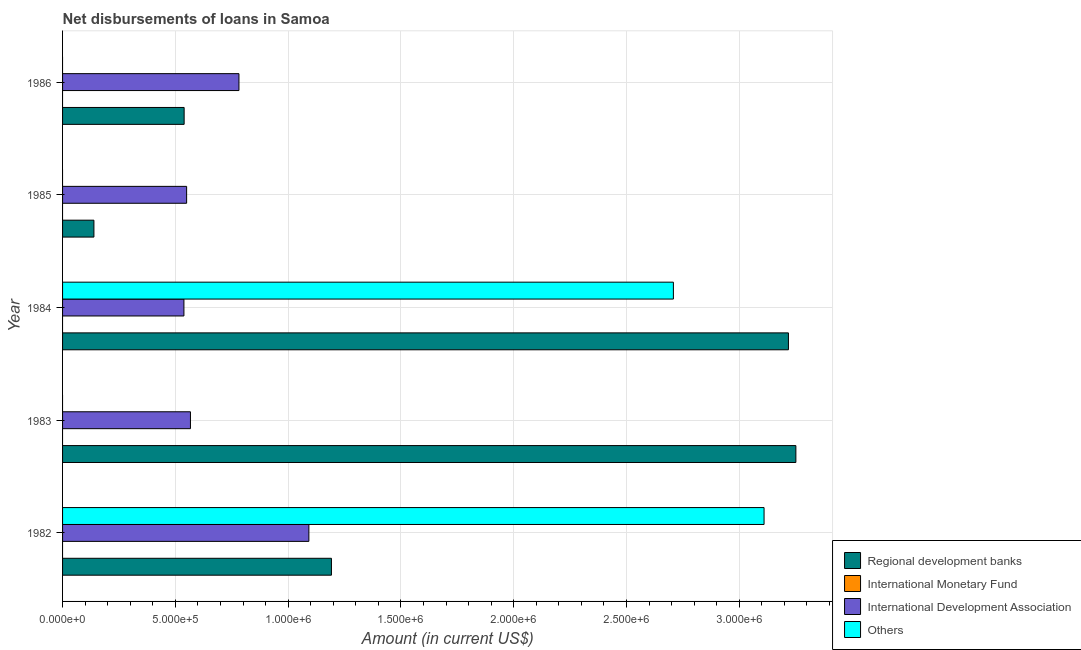Are the number of bars per tick equal to the number of legend labels?
Offer a terse response. No. Are the number of bars on each tick of the Y-axis equal?
Offer a terse response. No. What is the label of the 4th group of bars from the top?
Provide a succinct answer. 1983. In how many cases, is the number of bars for a given year not equal to the number of legend labels?
Provide a short and direct response. 5. Across all years, what is the maximum amount of loan disimbursed by other organisations?
Give a very brief answer. 3.11e+06. Across all years, what is the minimum amount of loan disimbursed by regional development banks?
Give a very brief answer. 1.39e+05. What is the total amount of loan disimbursed by regional development banks in the graph?
Offer a very short reply. 8.34e+06. What is the difference between the amount of loan disimbursed by regional development banks in 1982 and that in 1984?
Give a very brief answer. -2.03e+06. What is the difference between the amount of loan disimbursed by other organisations in 1986 and the amount of loan disimbursed by regional development banks in 1982?
Give a very brief answer. -1.19e+06. What is the average amount of loan disimbursed by other organisations per year?
Ensure brevity in your answer.  1.16e+06. In the year 1982, what is the difference between the amount of loan disimbursed by international development association and amount of loan disimbursed by other organisations?
Give a very brief answer. -2.02e+06. In how many years, is the amount of loan disimbursed by regional development banks greater than 1300000 US$?
Offer a terse response. 2. What is the ratio of the amount of loan disimbursed by international development association in 1984 to that in 1986?
Offer a terse response. 0.69. What is the difference between the highest and the second highest amount of loan disimbursed by regional development banks?
Offer a terse response. 3.30e+04. What is the difference between the highest and the lowest amount of loan disimbursed by international development association?
Your response must be concise. 5.54e+05. In how many years, is the amount of loan disimbursed by international development association greater than the average amount of loan disimbursed by international development association taken over all years?
Your answer should be compact. 2. Is it the case that in every year, the sum of the amount of loan disimbursed by other organisations and amount of loan disimbursed by international monetary fund is greater than the sum of amount of loan disimbursed by regional development banks and amount of loan disimbursed by international development association?
Provide a succinct answer. No. Are all the bars in the graph horizontal?
Your answer should be very brief. Yes. How many years are there in the graph?
Ensure brevity in your answer.  5. What is the difference between two consecutive major ticks on the X-axis?
Your answer should be compact. 5.00e+05. Are the values on the major ticks of X-axis written in scientific E-notation?
Keep it short and to the point. Yes. Does the graph contain grids?
Ensure brevity in your answer.  Yes. What is the title of the graph?
Give a very brief answer. Net disbursements of loans in Samoa. What is the label or title of the Y-axis?
Offer a very short reply. Year. What is the Amount (in current US$) of Regional development banks in 1982?
Your response must be concise. 1.19e+06. What is the Amount (in current US$) in International Monetary Fund in 1982?
Provide a succinct answer. 0. What is the Amount (in current US$) of International Development Association in 1982?
Provide a succinct answer. 1.09e+06. What is the Amount (in current US$) of Others in 1982?
Provide a short and direct response. 3.11e+06. What is the Amount (in current US$) in Regional development banks in 1983?
Your answer should be very brief. 3.25e+06. What is the Amount (in current US$) of International Monetary Fund in 1983?
Offer a terse response. 0. What is the Amount (in current US$) of International Development Association in 1983?
Your response must be concise. 5.67e+05. What is the Amount (in current US$) in Regional development banks in 1984?
Offer a terse response. 3.22e+06. What is the Amount (in current US$) in International Monetary Fund in 1984?
Make the answer very short. 0. What is the Amount (in current US$) in International Development Association in 1984?
Ensure brevity in your answer.  5.38e+05. What is the Amount (in current US$) of Others in 1984?
Your answer should be compact. 2.71e+06. What is the Amount (in current US$) of Regional development banks in 1985?
Your answer should be very brief. 1.39e+05. What is the Amount (in current US$) in International Monetary Fund in 1985?
Provide a succinct answer. 0. What is the Amount (in current US$) of International Development Association in 1985?
Your answer should be compact. 5.50e+05. What is the Amount (in current US$) of Others in 1985?
Make the answer very short. 0. What is the Amount (in current US$) of Regional development banks in 1986?
Keep it short and to the point. 5.39e+05. What is the Amount (in current US$) in International Development Association in 1986?
Your answer should be very brief. 7.82e+05. What is the Amount (in current US$) of Others in 1986?
Offer a terse response. 0. Across all years, what is the maximum Amount (in current US$) in Regional development banks?
Provide a succinct answer. 3.25e+06. Across all years, what is the maximum Amount (in current US$) in International Development Association?
Make the answer very short. 1.09e+06. Across all years, what is the maximum Amount (in current US$) in Others?
Your answer should be very brief. 3.11e+06. Across all years, what is the minimum Amount (in current US$) of Regional development banks?
Your answer should be very brief. 1.39e+05. Across all years, what is the minimum Amount (in current US$) in International Development Association?
Your answer should be compact. 5.38e+05. What is the total Amount (in current US$) in Regional development banks in the graph?
Offer a terse response. 8.34e+06. What is the total Amount (in current US$) in International Development Association in the graph?
Provide a succinct answer. 3.53e+06. What is the total Amount (in current US$) of Others in the graph?
Make the answer very short. 5.82e+06. What is the difference between the Amount (in current US$) in Regional development banks in 1982 and that in 1983?
Keep it short and to the point. -2.06e+06. What is the difference between the Amount (in current US$) in International Development Association in 1982 and that in 1983?
Provide a succinct answer. 5.25e+05. What is the difference between the Amount (in current US$) of Regional development banks in 1982 and that in 1984?
Your answer should be compact. -2.03e+06. What is the difference between the Amount (in current US$) in International Development Association in 1982 and that in 1984?
Offer a very short reply. 5.54e+05. What is the difference between the Amount (in current US$) of Others in 1982 and that in 1984?
Keep it short and to the point. 4.02e+05. What is the difference between the Amount (in current US$) of Regional development banks in 1982 and that in 1985?
Offer a terse response. 1.05e+06. What is the difference between the Amount (in current US$) in International Development Association in 1982 and that in 1985?
Provide a succinct answer. 5.42e+05. What is the difference between the Amount (in current US$) in Regional development banks in 1982 and that in 1986?
Make the answer very short. 6.53e+05. What is the difference between the Amount (in current US$) in Regional development banks in 1983 and that in 1984?
Provide a succinct answer. 3.30e+04. What is the difference between the Amount (in current US$) of International Development Association in 1983 and that in 1984?
Provide a short and direct response. 2.90e+04. What is the difference between the Amount (in current US$) in Regional development banks in 1983 and that in 1985?
Your response must be concise. 3.11e+06. What is the difference between the Amount (in current US$) in International Development Association in 1983 and that in 1985?
Make the answer very short. 1.70e+04. What is the difference between the Amount (in current US$) in Regional development banks in 1983 and that in 1986?
Make the answer very short. 2.71e+06. What is the difference between the Amount (in current US$) of International Development Association in 1983 and that in 1986?
Your answer should be compact. -2.15e+05. What is the difference between the Amount (in current US$) of Regional development banks in 1984 and that in 1985?
Your answer should be compact. 3.08e+06. What is the difference between the Amount (in current US$) in International Development Association in 1984 and that in 1985?
Provide a short and direct response. -1.20e+04. What is the difference between the Amount (in current US$) in Regional development banks in 1984 and that in 1986?
Keep it short and to the point. 2.68e+06. What is the difference between the Amount (in current US$) in International Development Association in 1984 and that in 1986?
Keep it short and to the point. -2.44e+05. What is the difference between the Amount (in current US$) of Regional development banks in 1985 and that in 1986?
Keep it short and to the point. -4.00e+05. What is the difference between the Amount (in current US$) in International Development Association in 1985 and that in 1986?
Offer a very short reply. -2.32e+05. What is the difference between the Amount (in current US$) in Regional development banks in 1982 and the Amount (in current US$) in International Development Association in 1983?
Provide a short and direct response. 6.25e+05. What is the difference between the Amount (in current US$) of Regional development banks in 1982 and the Amount (in current US$) of International Development Association in 1984?
Provide a succinct answer. 6.54e+05. What is the difference between the Amount (in current US$) in Regional development banks in 1982 and the Amount (in current US$) in Others in 1984?
Your answer should be compact. -1.52e+06. What is the difference between the Amount (in current US$) of International Development Association in 1982 and the Amount (in current US$) of Others in 1984?
Provide a short and direct response. -1.62e+06. What is the difference between the Amount (in current US$) of Regional development banks in 1982 and the Amount (in current US$) of International Development Association in 1985?
Make the answer very short. 6.42e+05. What is the difference between the Amount (in current US$) in Regional development banks in 1982 and the Amount (in current US$) in International Development Association in 1986?
Offer a terse response. 4.10e+05. What is the difference between the Amount (in current US$) in Regional development banks in 1983 and the Amount (in current US$) in International Development Association in 1984?
Offer a very short reply. 2.71e+06. What is the difference between the Amount (in current US$) of Regional development banks in 1983 and the Amount (in current US$) of Others in 1984?
Ensure brevity in your answer.  5.43e+05. What is the difference between the Amount (in current US$) of International Development Association in 1983 and the Amount (in current US$) of Others in 1984?
Your answer should be compact. -2.14e+06. What is the difference between the Amount (in current US$) in Regional development banks in 1983 and the Amount (in current US$) in International Development Association in 1985?
Your response must be concise. 2.70e+06. What is the difference between the Amount (in current US$) in Regional development banks in 1983 and the Amount (in current US$) in International Development Association in 1986?
Your response must be concise. 2.47e+06. What is the difference between the Amount (in current US$) of Regional development banks in 1984 and the Amount (in current US$) of International Development Association in 1985?
Offer a very short reply. 2.67e+06. What is the difference between the Amount (in current US$) in Regional development banks in 1984 and the Amount (in current US$) in International Development Association in 1986?
Keep it short and to the point. 2.44e+06. What is the difference between the Amount (in current US$) in Regional development banks in 1985 and the Amount (in current US$) in International Development Association in 1986?
Your answer should be very brief. -6.43e+05. What is the average Amount (in current US$) in Regional development banks per year?
Keep it short and to the point. 1.67e+06. What is the average Amount (in current US$) of International Development Association per year?
Keep it short and to the point. 7.06e+05. What is the average Amount (in current US$) of Others per year?
Give a very brief answer. 1.16e+06. In the year 1982, what is the difference between the Amount (in current US$) of Regional development banks and Amount (in current US$) of International Development Association?
Provide a short and direct response. 1.00e+05. In the year 1982, what is the difference between the Amount (in current US$) of Regional development banks and Amount (in current US$) of Others?
Your response must be concise. -1.92e+06. In the year 1982, what is the difference between the Amount (in current US$) of International Development Association and Amount (in current US$) of Others?
Offer a very short reply. -2.02e+06. In the year 1983, what is the difference between the Amount (in current US$) of Regional development banks and Amount (in current US$) of International Development Association?
Your answer should be compact. 2.68e+06. In the year 1984, what is the difference between the Amount (in current US$) in Regional development banks and Amount (in current US$) in International Development Association?
Offer a very short reply. 2.68e+06. In the year 1984, what is the difference between the Amount (in current US$) of Regional development banks and Amount (in current US$) of Others?
Your answer should be very brief. 5.10e+05. In the year 1984, what is the difference between the Amount (in current US$) of International Development Association and Amount (in current US$) of Others?
Make the answer very short. -2.17e+06. In the year 1985, what is the difference between the Amount (in current US$) in Regional development banks and Amount (in current US$) in International Development Association?
Offer a very short reply. -4.11e+05. In the year 1986, what is the difference between the Amount (in current US$) of Regional development banks and Amount (in current US$) of International Development Association?
Offer a very short reply. -2.43e+05. What is the ratio of the Amount (in current US$) of Regional development banks in 1982 to that in 1983?
Your answer should be very brief. 0.37. What is the ratio of the Amount (in current US$) of International Development Association in 1982 to that in 1983?
Give a very brief answer. 1.93. What is the ratio of the Amount (in current US$) of Regional development banks in 1982 to that in 1984?
Ensure brevity in your answer.  0.37. What is the ratio of the Amount (in current US$) of International Development Association in 1982 to that in 1984?
Ensure brevity in your answer.  2.03. What is the ratio of the Amount (in current US$) of Others in 1982 to that in 1984?
Your answer should be compact. 1.15. What is the ratio of the Amount (in current US$) of Regional development banks in 1982 to that in 1985?
Give a very brief answer. 8.58. What is the ratio of the Amount (in current US$) in International Development Association in 1982 to that in 1985?
Offer a very short reply. 1.99. What is the ratio of the Amount (in current US$) in Regional development banks in 1982 to that in 1986?
Provide a succinct answer. 2.21. What is the ratio of the Amount (in current US$) in International Development Association in 1982 to that in 1986?
Keep it short and to the point. 1.4. What is the ratio of the Amount (in current US$) of Regional development banks in 1983 to that in 1984?
Your answer should be very brief. 1.01. What is the ratio of the Amount (in current US$) of International Development Association in 1983 to that in 1984?
Your response must be concise. 1.05. What is the ratio of the Amount (in current US$) of Regional development banks in 1983 to that in 1985?
Offer a terse response. 23.39. What is the ratio of the Amount (in current US$) of International Development Association in 1983 to that in 1985?
Offer a terse response. 1.03. What is the ratio of the Amount (in current US$) in Regional development banks in 1983 to that in 1986?
Make the answer very short. 6.03. What is the ratio of the Amount (in current US$) of International Development Association in 1983 to that in 1986?
Give a very brief answer. 0.73. What is the ratio of the Amount (in current US$) in Regional development banks in 1984 to that in 1985?
Give a very brief answer. 23.15. What is the ratio of the Amount (in current US$) of International Development Association in 1984 to that in 1985?
Your answer should be very brief. 0.98. What is the ratio of the Amount (in current US$) of Regional development banks in 1984 to that in 1986?
Your response must be concise. 5.97. What is the ratio of the Amount (in current US$) in International Development Association in 1984 to that in 1986?
Ensure brevity in your answer.  0.69. What is the ratio of the Amount (in current US$) of Regional development banks in 1985 to that in 1986?
Provide a succinct answer. 0.26. What is the ratio of the Amount (in current US$) in International Development Association in 1985 to that in 1986?
Give a very brief answer. 0.7. What is the difference between the highest and the second highest Amount (in current US$) of Regional development banks?
Provide a succinct answer. 3.30e+04. What is the difference between the highest and the lowest Amount (in current US$) in Regional development banks?
Your response must be concise. 3.11e+06. What is the difference between the highest and the lowest Amount (in current US$) of International Development Association?
Your answer should be compact. 5.54e+05. What is the difference between the highest and the lowest Amount (in current US$) in Others?
Offer a terse response. 3.11e+06. 